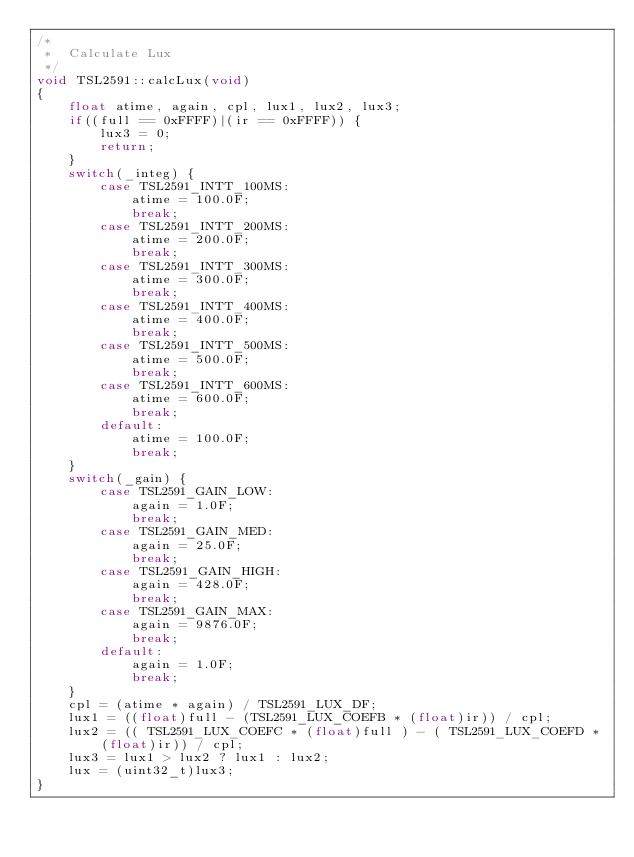Convert code to text. <code><loc_0><loc_0><loc_500><loc_500><_C++_>/*
 *  Calculate Lux
 */
void TSL2591::calcLux(void)
{
    float atime, again, cpl, lux1, lux2, lux3;
    if((full == 0xFFFF)|(ir == 0xFFFF)) {
        lux3 = 0;
        return;
    }
    switch(_integ) {
        case TSL2591_INTT_100MS:
            atime = 100.0F;
            break;
        case TSL2591_INTT_200MS:
            atime = 200.0F;
            break;
        case TSL2591_INTT_300MS:
            atime = 300.0F;
            break;
        case TSL2591_INTT_400MS:
            atime = 400.0F;
            break;
        case TSL2591_INTT_500MS:
            atime = 500.0F;
            break;
        case TSL2591_INTT_600MS:
            atime = 600.0F;
            break;
        default:
            atime = 100.0F;
            break;
    }
    switch(_gain) {
        case TSL2591_GAIN_LOW:
            again = 1.0F;
            break;
        case TSL2591_GAIN_MED:
            again = 25.0F;
            break;
        case TSL2591_GAIN_HIGH:
            again = 428.0F;
            break;
        case TSL2591_GAIN_MAX:
            again = 9876.0F;
            break;
        default:
            again = 1.0F;
            break;
    }
    cpl = (atime * again) / TSL2591_LUX_DF;
    lux1 = ((float)full - (TSL2591_LUX_COEFB * (float)ir)) / cpl;
    lux2 = (( TSL2591_LUX_COEFC * (float)full ) - ( TSL2591_LUX_COEFD * (float)ir)) / cpl;
    lux3 = lux1 > lux2 ? lux1 : lux2;
    lux = (uint32_t)lux3;
}
</code> 